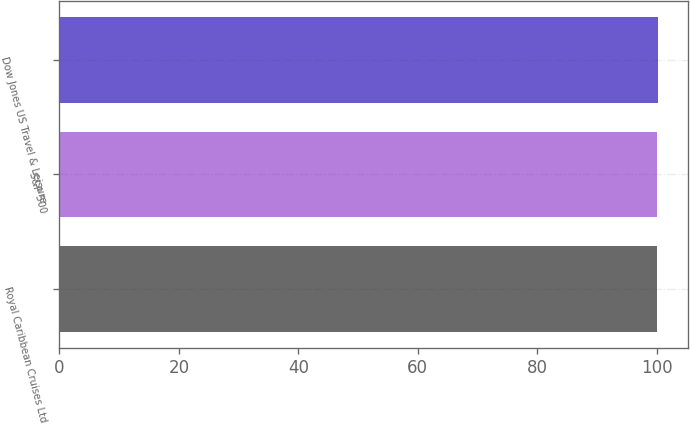<chart> <loc_0><loc_0><loc_500><loc_500><bar_chart><fcel>Royal Caribbean Cruises Ltd<fcel>S&P 500<fcel>Dow Jones US Travel & Leisure<nl><fcel>100<fcel>100.1<fcel>100.2<nl></chart> 